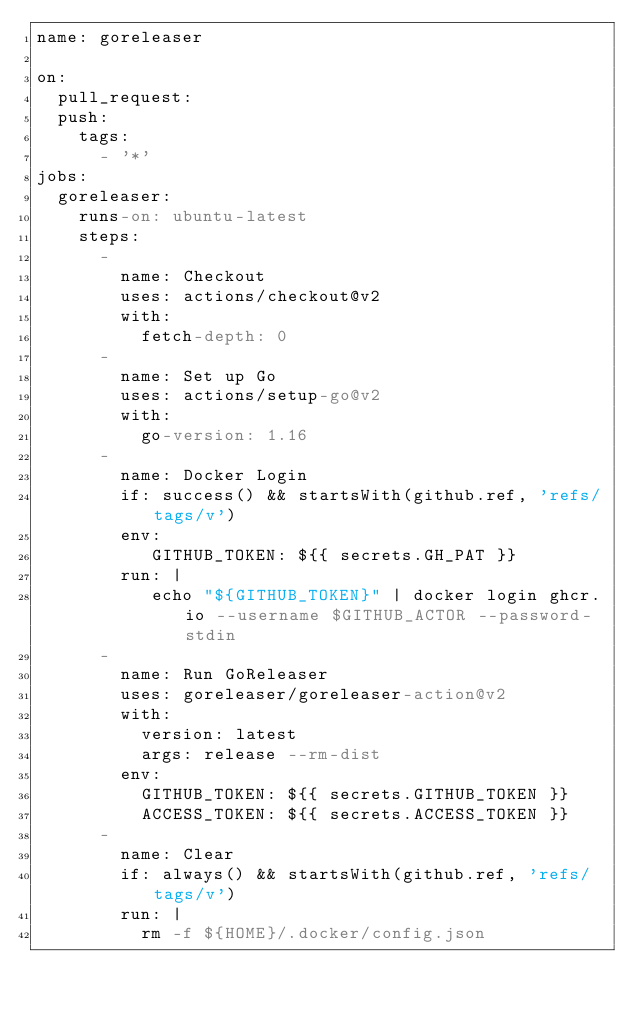<code> <loc_0><loc_0><loc_500><loc_500><_YAML_>name: goreleaser

on:
  pull_request:
  push:
    tags:
      - '*'
jobs:
  goreleaser:
    runs-on: ubuntu-latest
    steps:
      -
        name: Checkout
        uses: actions/checkout@v2
        with:
          fetch-depth: 0
      -
        name: Set up Go
        uses: actions/setup-go@v2
        with:
          go-version: 1.16
      -
        name: Docker Login
        if: success() && startsWith(github.ref, 'refs/tags/v')
        env:
           GITHUB_TOKEN: ${{ secrets.GH_PAT }}
        run: |
           echo "${GITHUB_TOKEN}" | docker login ghcr.io --username $GITHUB_ACTOR --password-stdin
      -
        name: Run GoReleaser
        uses: goreleaser/goreleaser-action@v2
        with:
          version: latest
          args: release --rm-dist
        env:
          GITHUB_TOKEN: ${{ secrets.GITHUB_TOKEN }}
          ACCESS_TOKEN: ${{ secrets.ACCESS_TOKEN }}
      -
        name: Clear
        if: always() && startsWith(github.ref, 'refs/tags/v')
        run: |
          rm -f ${HOME}/.docker/config.json</code> 